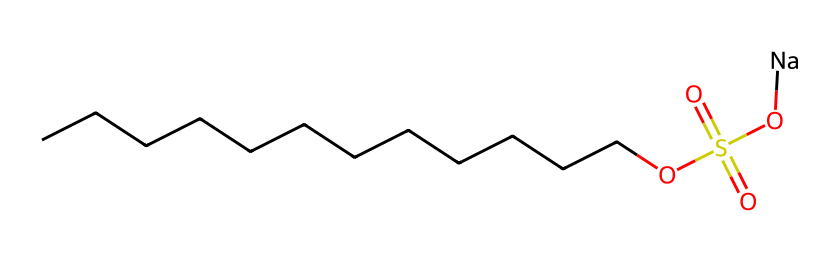What is the total number of carbon atoms in this detergent? Counting the 'C' symbols in the SMILES notation reveals there are 12 carbon atoms (CCCCCCCCCCCC indicates twelve connected carbons).
Answer: 12 How many sulfur atoms are present in this chemical? In the provided SMILES, there is one 'S' symbol, indicating the presence of one sulfur atom.
Answer: 1 What type of chemical structure does this detergent represent? The presence of a long carbon chain and a sulfonate group (OS(=O)(=O)O) indicates that this is an alkyl sulfonate detergent.
Answer: alkyl sulfonate What is the ionic component of this detergent? The notation includes '[Na]', which indicates that sodium is the ionic component or counterion in this detergent's structure.
Answer: sodium Does this detergent contain any functional groups? Yes, the presence of the sulfonate group (OS(=O)(=O)O) indicates that this detergent contains a sulfonate functional group, which is crucial for its detergent properties.
Answer: sulfonate How many oxygen atoms are found in this structure? In the notation, there are four 'O' symbols appearing, indicating that there are four oxygen atoms in total (from the sulfonate group and hydroxyl).
Answer: 4 Why is the long carbon chain significant for its detergent properties? The long carbon chain enhances the hydrophobic characteristics of the detergent, allowing it to effectively break down grease and oily substances during cleaning processes.
Answer: enhances hydrophobicity 